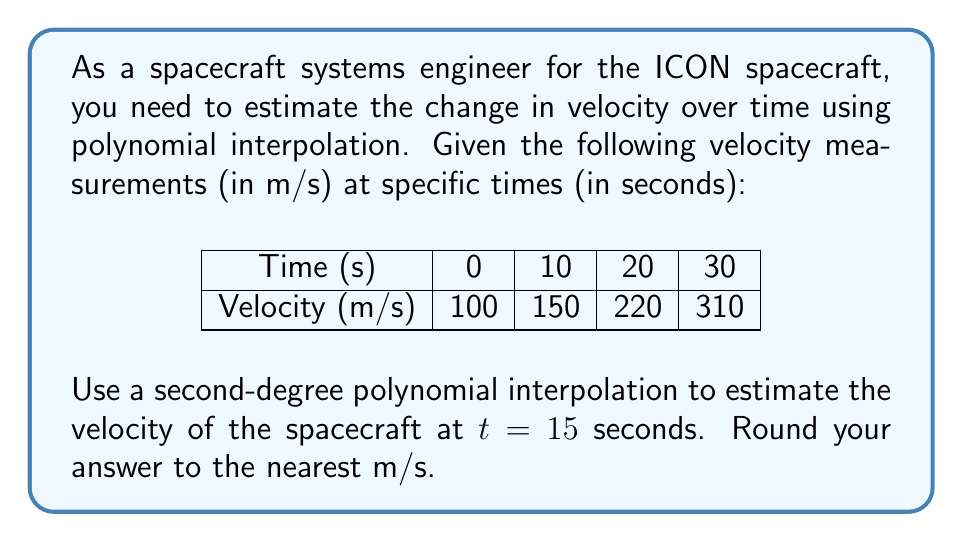Could you help me with this problem? To solve this problem, we'll use Lagrange polynomial interpolation for a second-degree polynomial. The steps are as follows:

1) The Lagrange interpolation polynomial is given by:
   $$P(x) = \sum_{i=0}^n y_i \cdot L_i(x)$$
   where $L_i(x)$ are the Lagrange basis polynomials.

2) For a second-degree polynomial, we'll use three points: (0, 100), (10, 150), and (20, 220).

3) The Lagrange basis polynomials are:
   $$L_0(x) = \frac{(x-10)(x-20)}{(0-10)(0-20)}$$
   $$L_1(x) = \frac{(x-0)(x-20)}{(10-0)(10-20)}$$
   $$L_2(x) = \frac{(x-0)(x-10)}{(20-0)(20-10)}$$

4) Simplifying:
   $$L_0(x) = \frac{x^2-30x+200}{200}$$
   $$L_1(x) = -\frac{x^2-20x}{100}$$
   $$L_2(x) = \frac{x^2-10x}{200}$$

5) The interpolation polynomial is:
   $$P(x) = 100 \cdot L_0(x) + 150 \cdot L_1(x) + 220 \cdot L_2(x)$$

6) Substituting the simplified Lagrange polynomials:
   $$P(x) = 100 \cdot \frac{x^2-30x+200}{200} + 150 \cdot (-\frac{x^2-20x}{100}) + 220 \cdot \frac{x^2-10x}{200}$$

7) Simplifying:
   $$P(x) = \frac{x^2-30x+200}{2} - \frac{3x^2-60x}{2} + \frac{11x^2-110x}{10}$$
   $$P(x) = \frac{5x^2-150x+200}{2} - \frac{15x^2-300x}{10} + \frac{11x^2-110x}{10}$$
   $$P(x) = \frac{25x^2-750x+1000}{10} - \frac{15x^2-300x}{10} + \frac{11x^2-110x}{10}$$
   $$P(x) = \frac{21x^2-560x+1000}{10}$$
   $$P(x) = 2.1x^2 - 56x + 100$$

8) To find the velocity at t = 15 seconds, we substitute x = 15 into our polynomial:
   $$P(15) = 2.1(15)^2 - 56(15) + 100$$
   $$P(15) = 2.1(225) - 840 + 100$$
   $$P(15) = 472.5 - 740 = 187.5$$

9) Rounding to the nearest m/s:
   $$P(15) \approx 188 \text{ m/s}$$
Answer: 188 m/s 